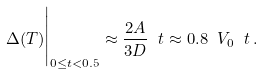<formula> <loc_0><loc_0><loc_500><loc_500>\Delta ( T ) \Big | _ { 0 \leq t < 0 . 5 } \approx \frac { 2 A } { 3 D } \ t \approx 0 . 8 \ V _ { 0 } \ t \, .</formula> 